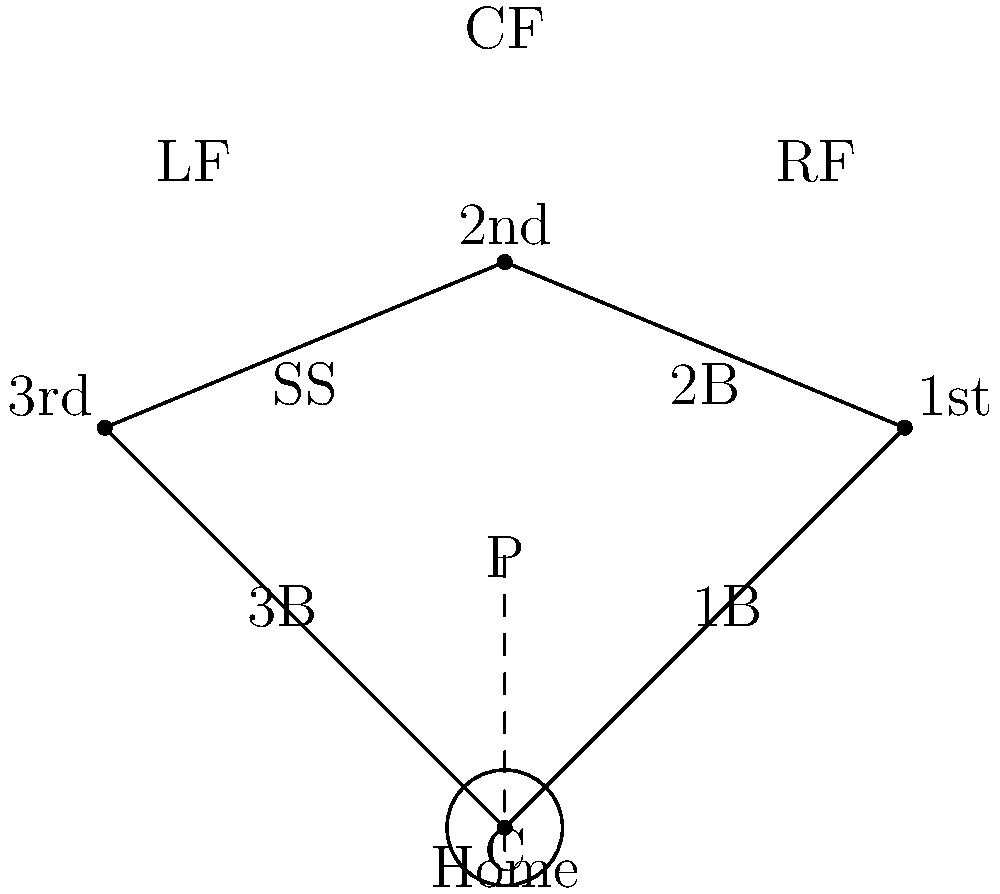In a standard baseball diamond layout, what is the distance between home plate and second base, given that the distance between adjacent bases is 90 feet? To find the distance between home plate and second base, we can follow these steps:

1. Recognize that the baseball diamond forms a square, with each side measuring 90 feet.

2. Home plate and second base are at opposite corners of this square.

3. The line connecting home plate and second base forms the diagonal of the square.

4. In a square, the diagonal can be calculated using the Pythagorean theorem:
   $d^2 = a^2 + b^2$, where $d$ is the diagonal and $a$ and $b$ are the sides of the square.

5. Substituting the known values:
   $d^2 = 90^2 + 90^2 = 8100 + 8100 = 16200$

6. Taking the square root of both sides:
   $d = \sqrt{16200} = 90\sqrt{2} \approx 127.28$ feet

Therefore, the distance between home plate and second base is $90\sqrt{2}$ feet, or approximately 127.28 feet.
Answer: $90\sqrt{2}$ feet (or approximately 127.28 feet) 